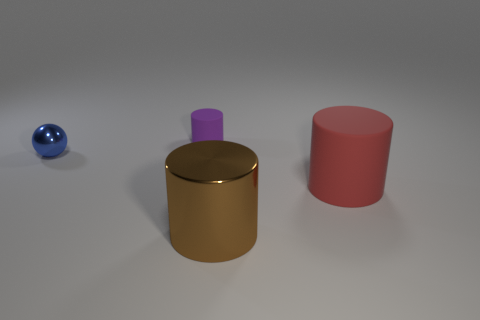Are there an equal number of red rubber cylinders that are behind the blue object and tiny purple matte objects that are to the left of the brown cylinder?
Offer a terse response. No. There is a tiny thing behind the blue thing; is its color the same as the shiny object behind the large red object?
Offer a terse response. No. Is the number of tiny matte things that are right of the purple matte cylinder greater than the number of big yellow rubber objects?
Give a very brief answer. No. What is the small purple cylinder made of?
Provide a short and direct response. Rubber. What is the shape of the big brown object that is made of the same material as the small blue thing?
Your response must be concise. Cylinder. There is a rubber object that is on the left side of the metallic thing in front of the tiny blue metal object; what size is it?
Make the answer very short. Small. The object that is left of the purple thing is what color?
Provide a succinct answer. Blue. Is there another brown object of the same shape as the big rubber thing?
Offer a terse response. Yes. Is the number of large matte cylinders behind the red thing less than the number of big red matte cylinders that are in front of the large brown cylinder?
Your answer should be compact. No. The sphere has what color?
Your answer should be compact. Blue. 